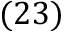<formula> <loc_0><loc_0><loc_500><loc_500>( 2 3 )</formula> 